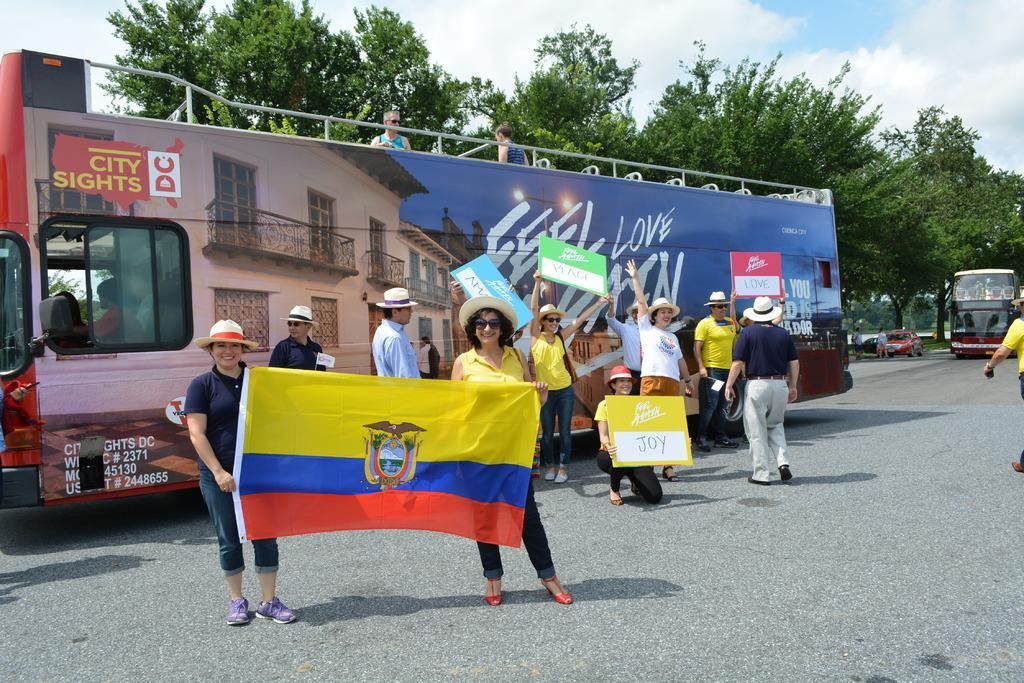Could you give a brief overview of what you see in this image? In this image I can a road and on it I can see few people are standing. I can see the front two are holding a flag and in the background I can see few of them are holding boards. On these words I can see something is written. In the background I can see few buses, a car, number of trees. clouds, the sky and on the left bus I can see something is written. I can also see these people are wearing caps. 